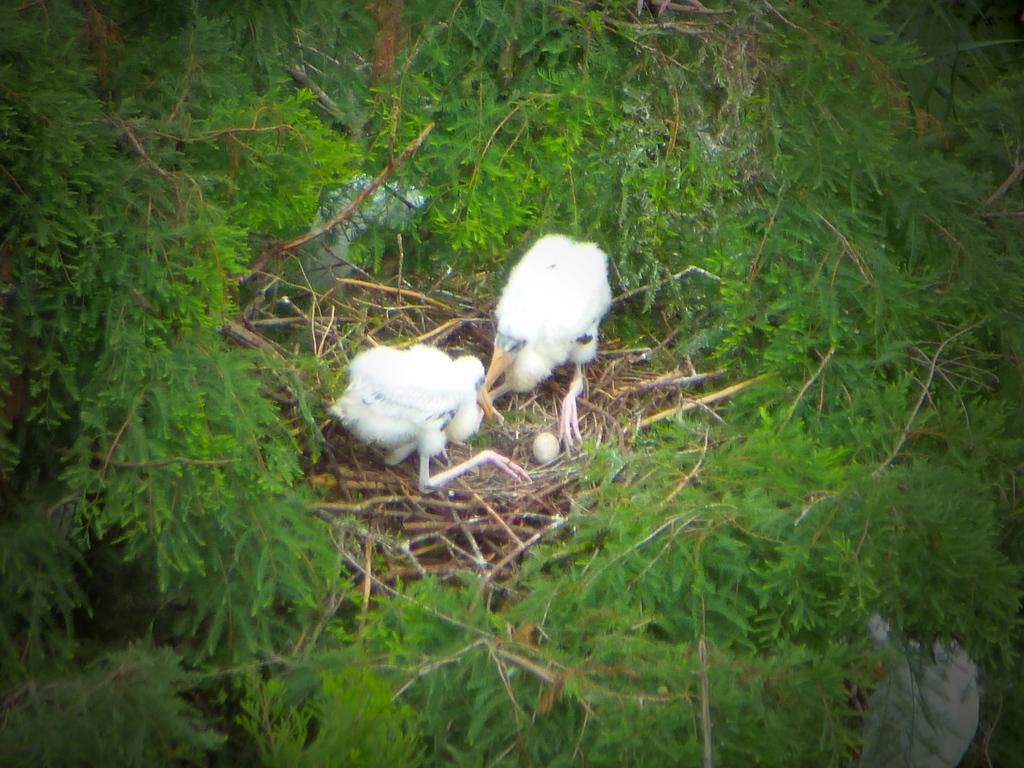Please provide a concise description of this image. In this image I can see a nest in the center. There are 2 white birds and an egg in the nest. There are plants around the nest. 